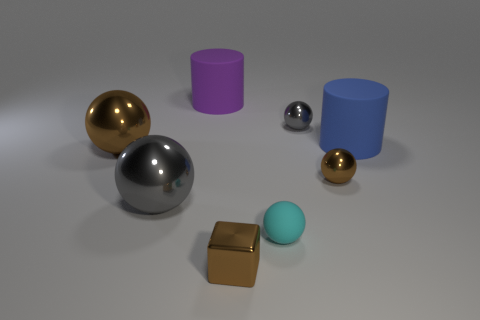What number of objects are gray things or large matte cylinders?
Keep it short and to the point. 4. The rubber sphere has what size?
Ensure brevity in your answer.  Small. Is the number of spheres less than the number of green matte cubes?
Make the answer very short. No. What number of objects are the same color as the small block?
Ensure brevity in your answer.  2. Do the cylinder that is left of the large blue matte cylinder and the tiny block have the same color?
Your answer should be compact. No. There is a brown thing right of the small brown block; what is its shape?
Give a very brief answer. Sphere. Is there a small thing behind the object that is on the right side of the small brown sphere?
Your answer should be very brief. Yes. What number of big brown objects are the same material as the tiny gray thing?
Your response must be concise. 1. There is a gray shiny sphere in front of the brown ball that is right of the big shiny ball that is on the right side of the big brown object; what is its size?
Provide a short and direct response. Large. What number of small things are behind the shiny block?
Make the answer very short. 3. 